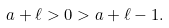Convert formula to latex. <formula><loc_0><loc_0><loc_500><loc_500>a + \ell > 0 > a + \ell - 1 .</formula> 